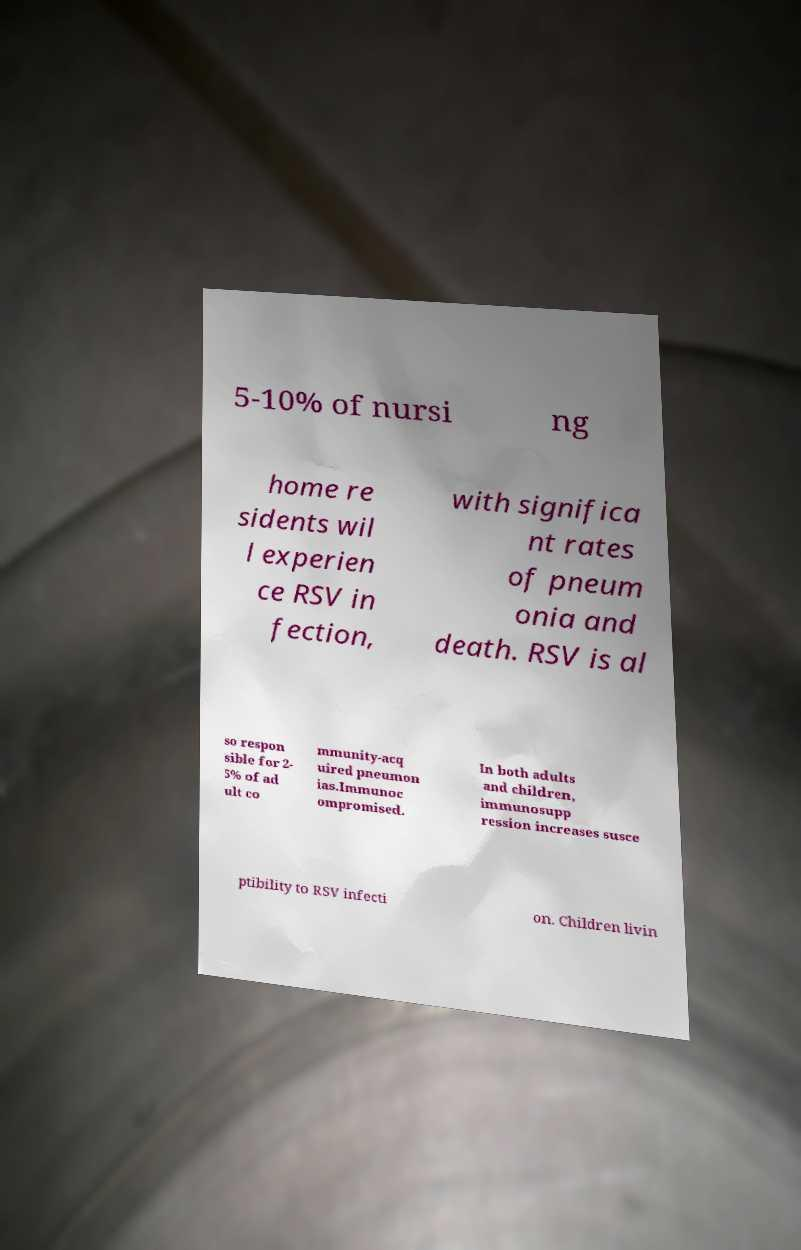Can you read and provide the text displayed in the image?This photo seems to have some interesting text. Can you extract and type it out for me? 5-10% of nursi ng home re sidents wil l experien ce RSV in fection, with significa nt rates of pneum onia and death. RSV is al so respon sible for 2- 5% of ad ult co mmunity-acq uired pneumon ias.Immunoc ompromised. In both adults and children, immunosupp ression increases susce ptibility to RSV infecti on. Children livin 